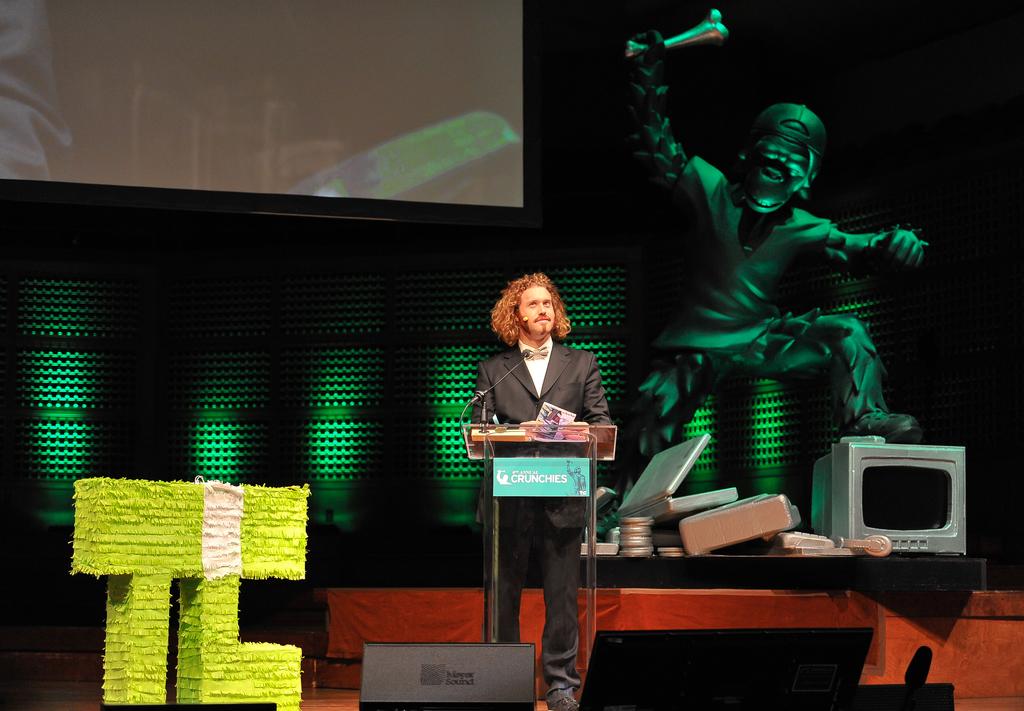What business does the speaker represent?
Your response must be concise. Crunchies. 